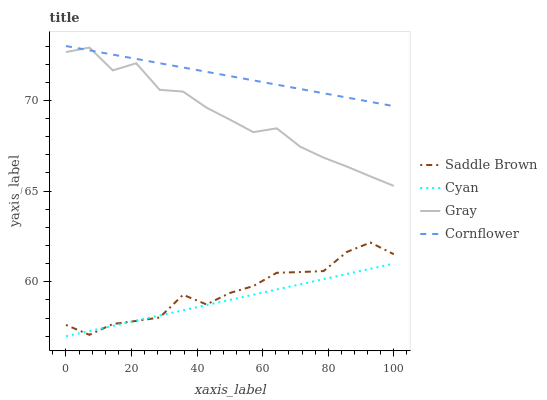Does Cyan have the minimum area under the curve?
Answer yes or no. Yes. Does Cornflower have the maximum area under the curve?
Answer yes or no. Yes. Does Saddle Brown have the minimum area under the curve?
Answer yes or no. No. Does Saddle Brown have the maximum area under the curve?
Answer yes or no. No. Is Cornflower the smoothest?
Answer yes or no. Yes. Is Gray the roughest?
Answer yes or no. Yes. Is Saddle Brown the smoothest?
Answer yes or no. No. Is Saddle Brown the roughest?
Answer yes or no. No. Does Cyan have the lowest value?
Answer yes or no. Yes. Does Saddle Brown have the lowest value?
Answer yes or no. No. Does Cornflower have the highest value?
Answer yes or no. Yes. Does Saddle Brown have the highest value?
Answer yes or no. No. Is Cyan less than Cornflower?
Answer yes or no. Yes. Is Cornflower greater than Cyan?
Answer yes or no. Yes. Does Cornflower intersect Gray?
Answer yes or no. Yes. Is Cornflower less than Gray?
Answer yes or no. No. Is Cornflower greater than Gray?
Answer yes or no. No. Does Cyan intersect Cornflower?
Answer yes or no. No. 